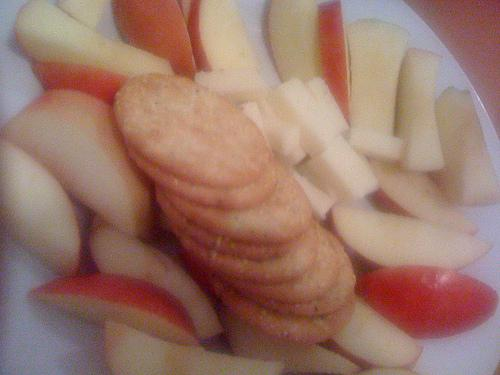Question: what color is the apple slices?
Choices:
A. Green.
B. Yellow.
C. Red and White.
D. Light orange.
Answer with the letter. Answer: C Question: what color are the crackers?
Choices:
A. Tan.
B. White.
C. Red.
D. Blue.
Answer with the letter. Answer: A Question: where was the photo taken?
Choices:
A. The living room.
B. The dining room.
C. Kitchen.
D. The basement.
Answer with the letter. Answer: C Question: when was the photo taken?
Choices:
A. Daytime.
B. In the afternoon.
C. In the evening.
D. Late last night.
Answer with the letter. Answer: A Question: what fruit is in the photo?
Choices:
A. An orange.
B. A pineapple.
C. A banana.
D. Apple.
Answer with the letter. Answer: D Question: what color is the table?
Choices:
A. Brown.
B. Black.
C. White.
D. Green.
Answer with the letter. Answer: A 